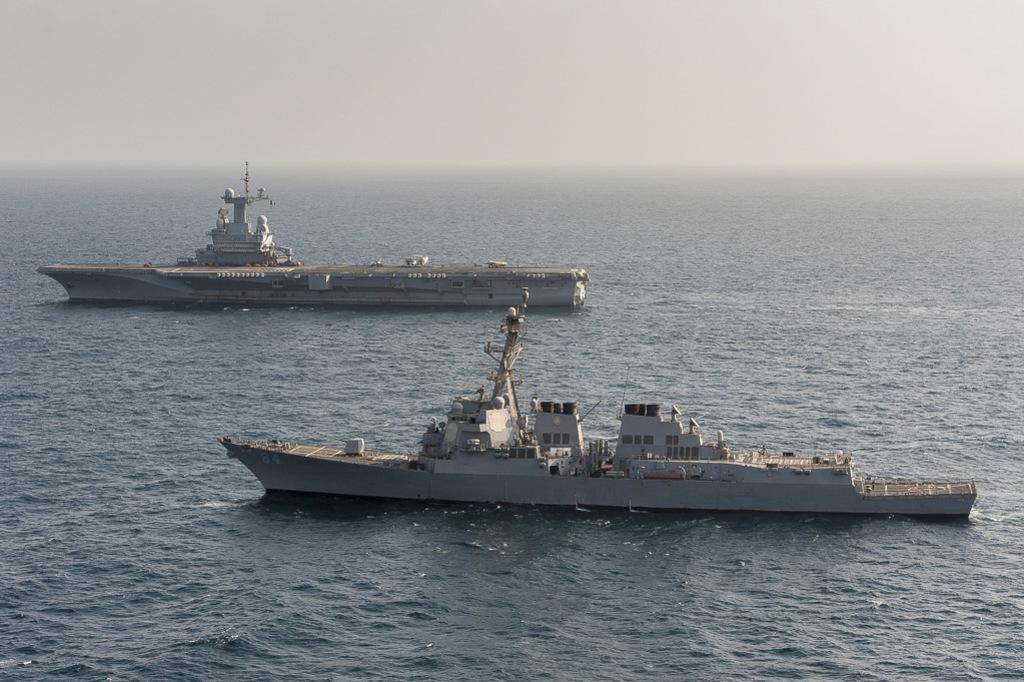Please provide a concise description of this image. In the image we can see two ships in the water and the foggy sky. 